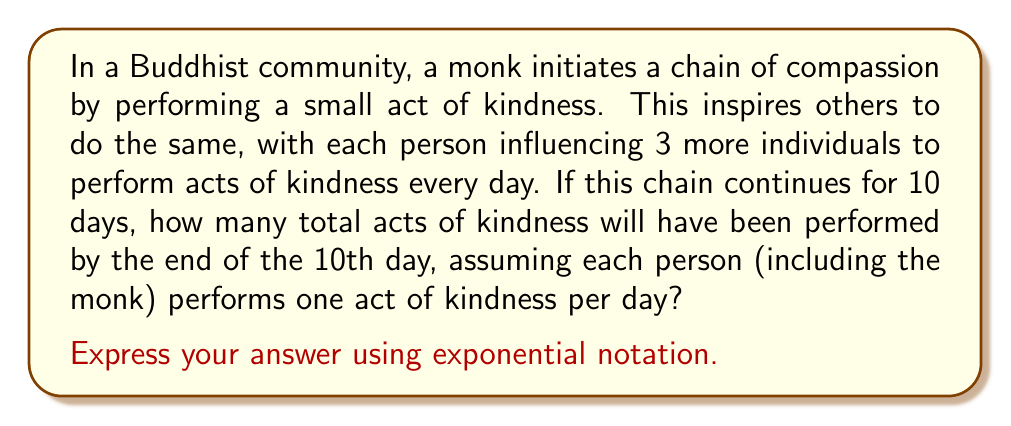Help me with this question. Let's approach this step-by-step:

1) On day 1, only the monk performs an act of kindness. So we have 1 act.

2) On day 2, the monk and 3 new people perform acts of kindness. So we have 1 + 3 = 4 acts.

3) On day 3, we have the original 4 people plus 3 new people for each of the 3 people from day 2. So we have 4 + (3 × 3) = 13 acts.

4) We can see that this forms a geometric sequence with a common ratio of 3.

5) The number of new people performing acts each day can be expressed as:
   Day 1: $3^0 = 1$
   Day 2: $3^1 = 3$
   Day 3: $3^2 = 9$
   ...
   Day 10: $3^9 = 19,683$

6) To find the total number of acts, we need to sum this geometric sequence from $3^0$ to $3^9$, and then multiply by 10 (as each person performs an act every day for 10 days).

7) The sum of a geometric sequence is given by the formula:
   $S_n = \frac{a(1-r^n)}{1-r}$ where $a$ is the first term, $r$ is the common ratio, and $n$ is the number of terms.

8) In our case, $a=1$, $r=3$, and $n=10$. So:

   $S_{10} = \frac{1(1-3^{10})}{1-3} = \frac{1-3^{10}}{-2} = \frac{3^{10}-1}{2}$

9) Therefore, the total number of people performing acts by day 10 is $\frac{3^{10}-1}{2}$

10) Multiplying this by 10 (for 10 days) gives us our final answer:

    $10 \times \frac{3^{10}-1}{2} = 5(3^{10}-1)$
Answer: $5(3^{10}-1)$ acts of kindness 